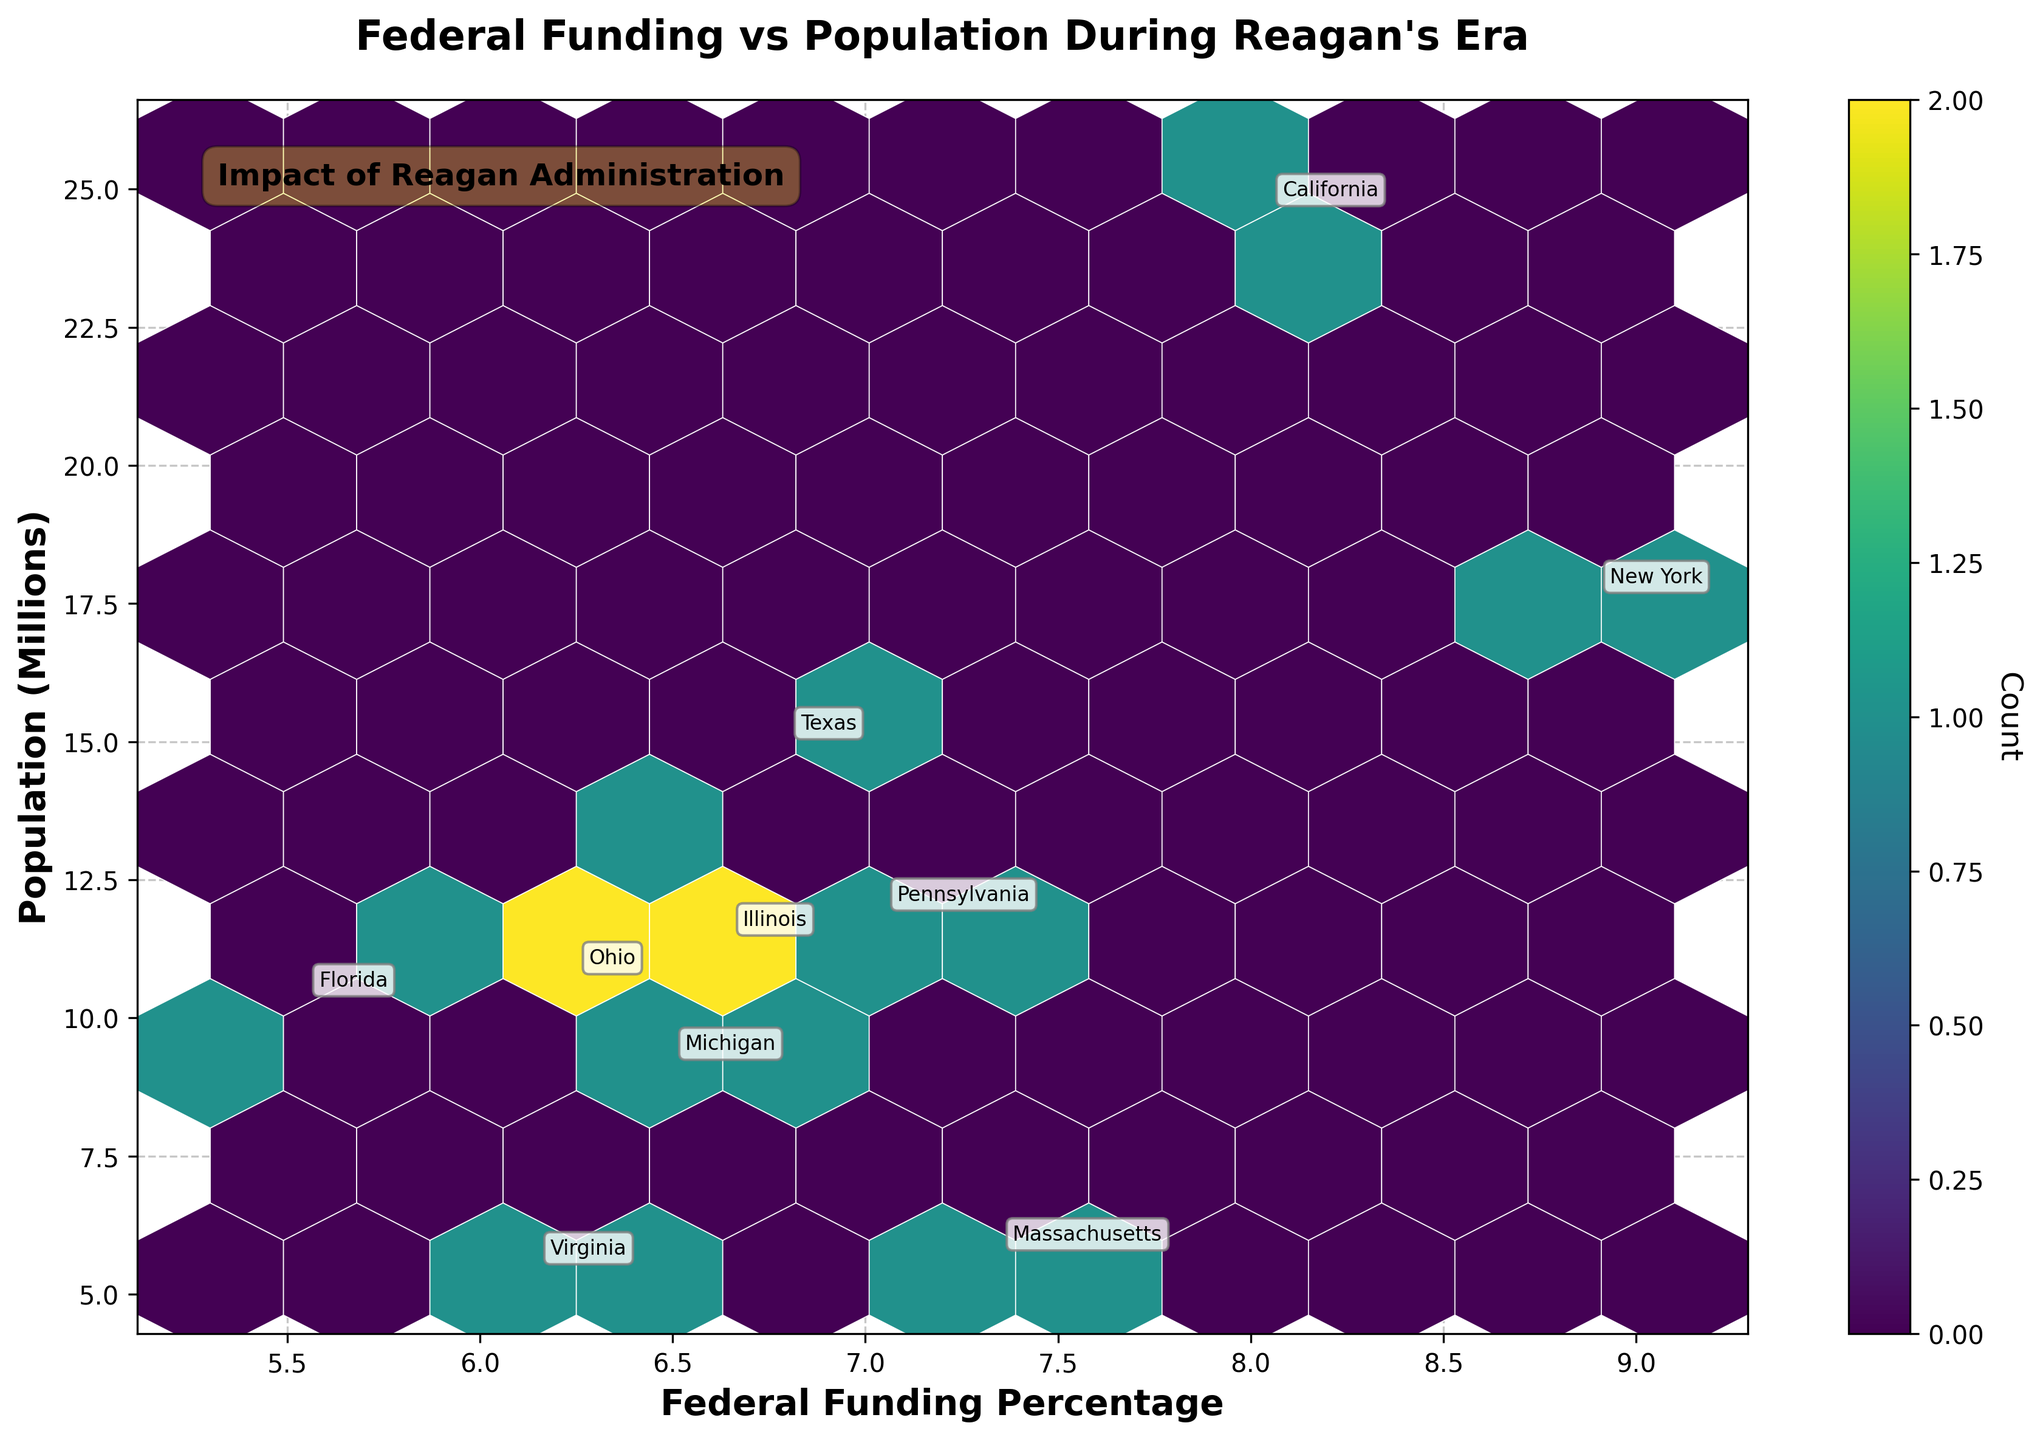What is the title of the hexbin plot? The title of the hexbin plot is located at the top of the figure and gives an overview of what the chart represents. The title is "Federal Funding vs Population During Reagan's Era".
Answer: Federal Funding vs Population During Reagan's Era What colors are primarily used in the hexbin plot? By visually examining the hexbin plot, one can see the colors used in the plot. The plot primarily uses shades of green and yellow, thanks to the 'viridis' color map.
Answer: Shades of green and yellow How is the count represented in the hexbin plot? The count in the hexbin plot is represented by the color intensity of the hexagons. The color bar on the right side of the plot provides a scale that shows the correlation between color intensity and count.
Answer: By color intensity Which state has the highest average federal funding percentage? By observing the annotated state labels on the hexbin plot, we compare the average federal funding percentages. New York appears to have the highest average, positioned around 8.9%.
Answer: New York Are there any states with an increasing trend in federal funding allocations from 1980 to 1984? Examining the annotated plots for each state, one can see if their federal funding percentages are higher in 1984 than in 1980. States like Texas and Florida show an increase.
Answer: Yes, Texas and Florida What is the highest population among the states plotted? Checking the 'Population (Millions)' axis and corresponding annotated states, New York and California have the highest populations, approximately 17.7 and 25.6 million respectively.
Answer: California Which two states have closely related populations but differ significantly in federal funding percentage? By comparing annotations, Pennsylvania and Ohio both show a population around 11.9 million, but their federal funding percentages are around 6.9% and 6.1%, respectively.
Answer: Pennsylvania and Ohio What is the primary trend in federal funding allocation from 1980 to 1984? Observing the hexbin plot, there seems to be a trend where some states either maintained stable funding or had slight decreases/increases. No drastic changes are evident.
Answer: Mostly stable with slight changes Which state has the smallest population with nearly proportional funding percentage? Observing the annotated state labels and hexbin distribution, Massachusetts appears to have a smaller population (~5.8 million) with a proportionally higher funding percentage (~7.2%).
Answer: Massachusetts 